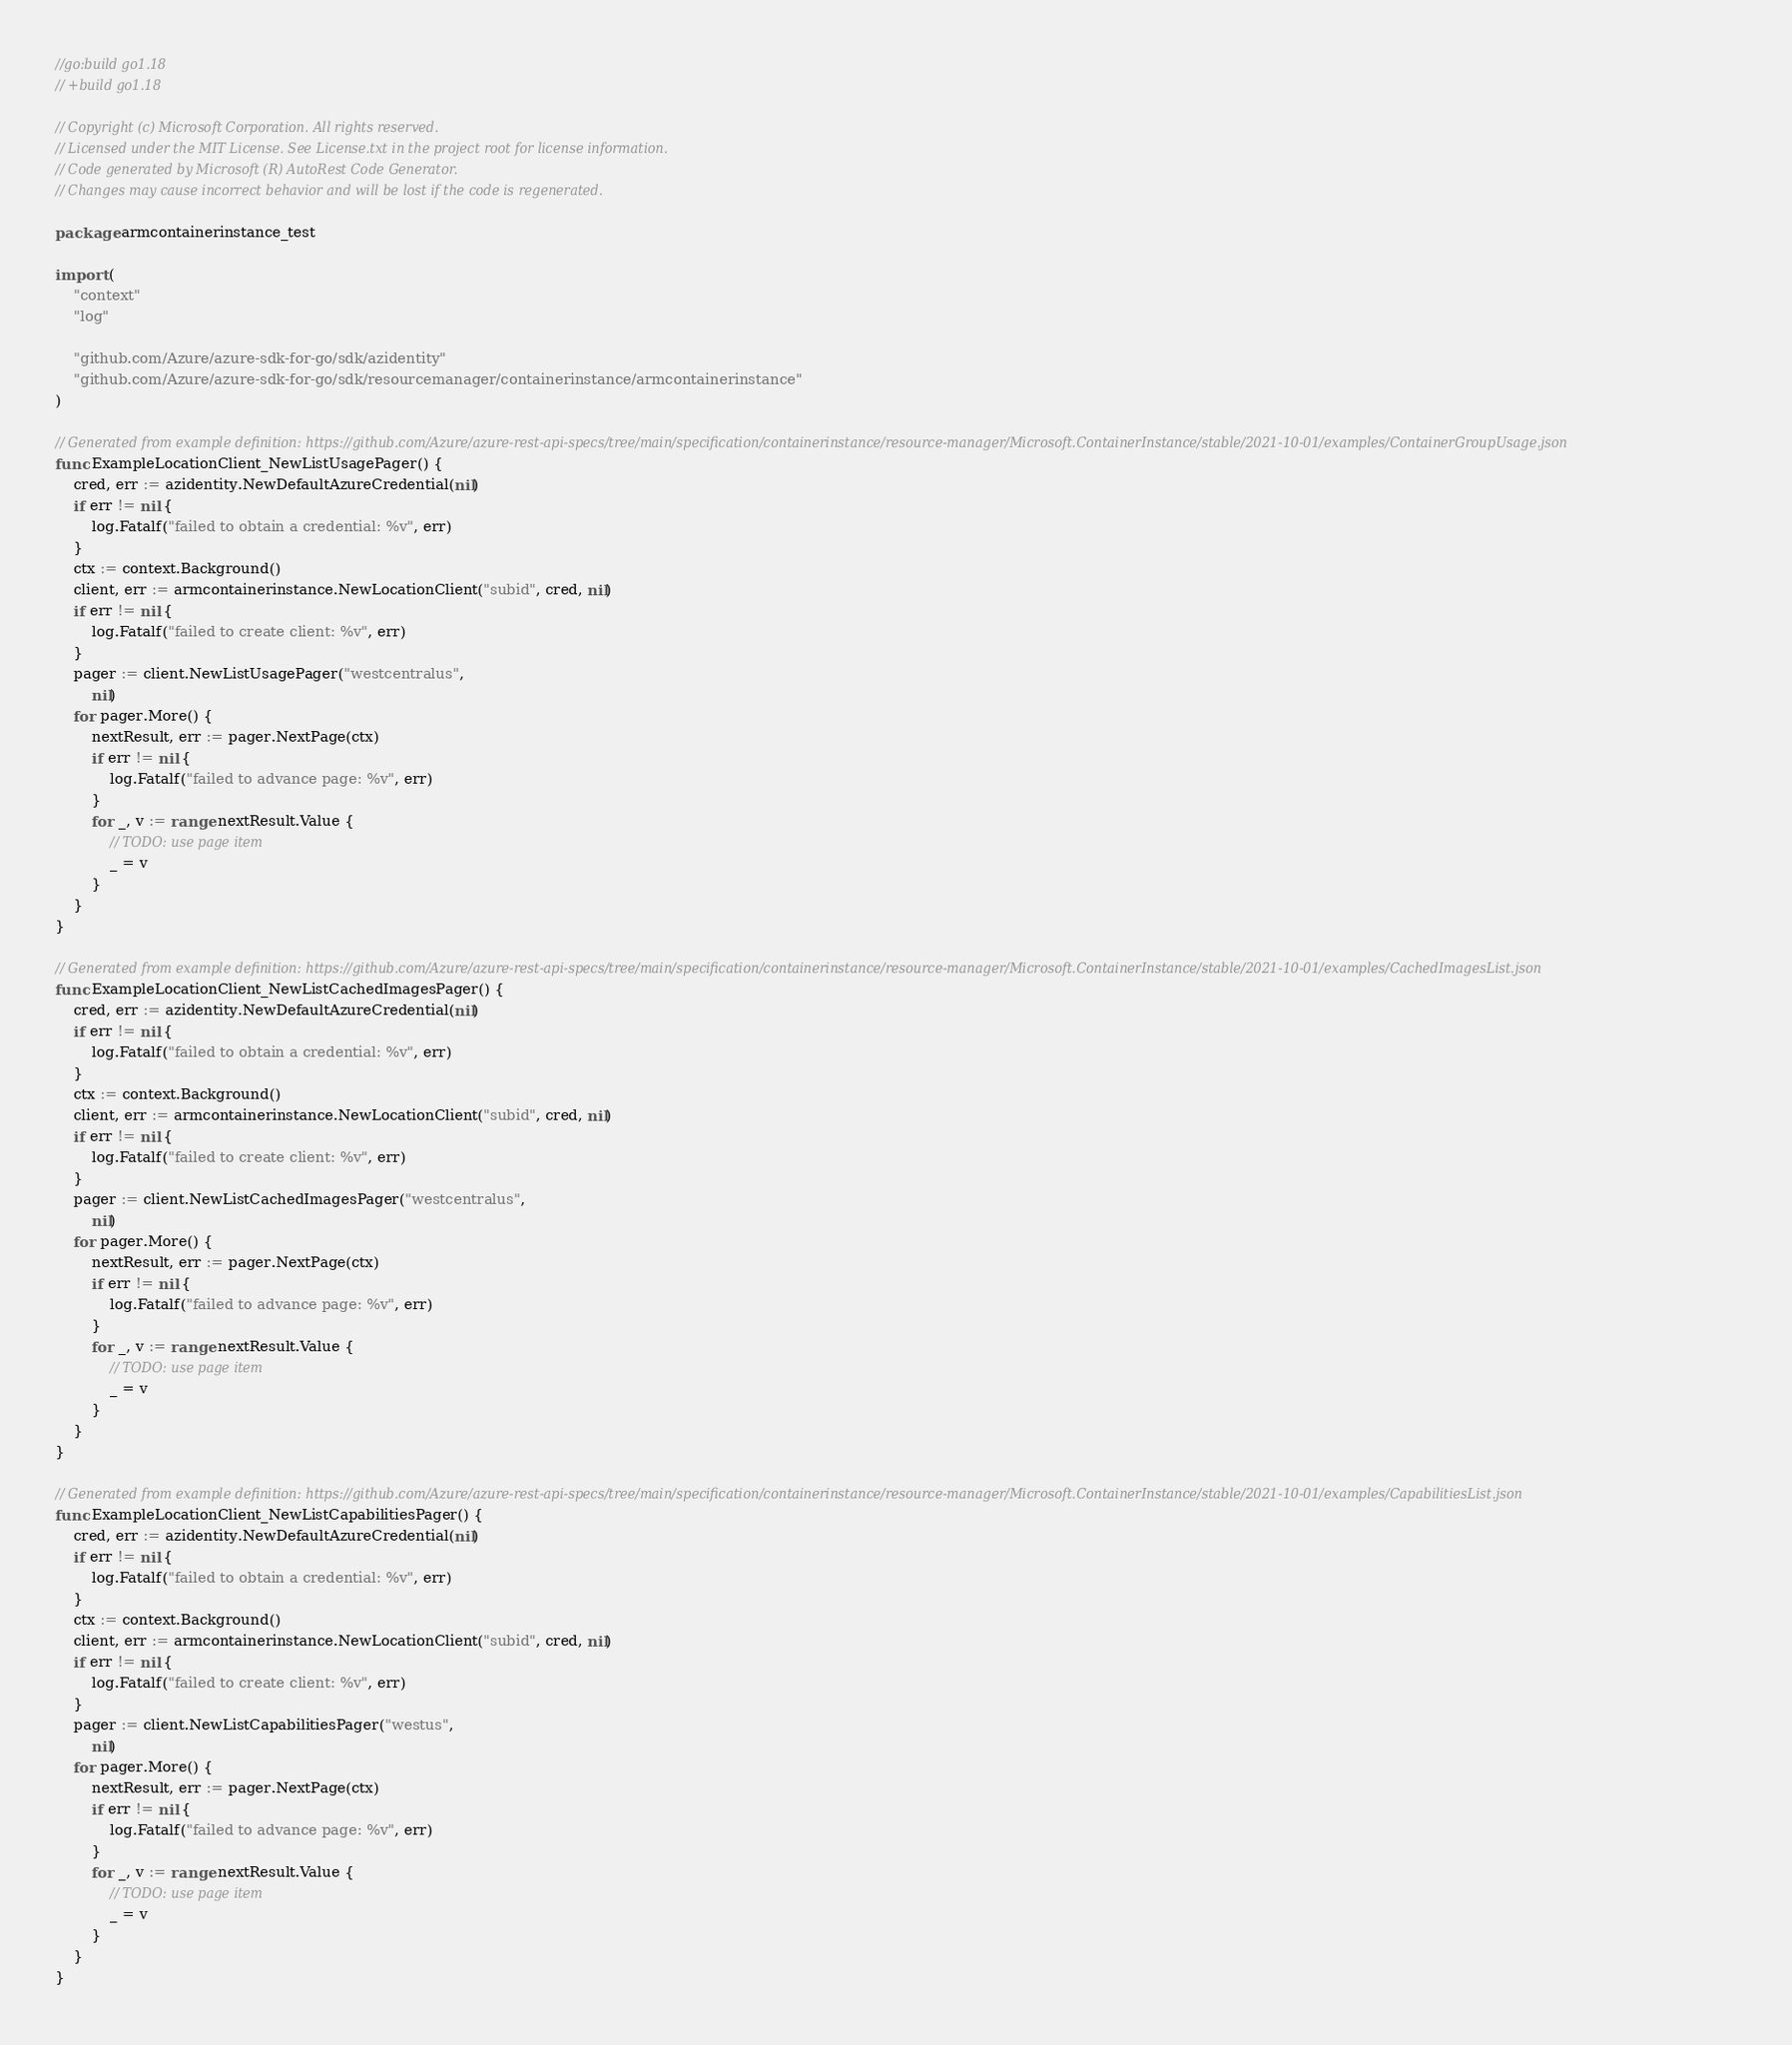Convert code to text. <code><loc_0><loc_0><loc_500><loc_500><_Go_>//go:build go1.18
// +build go1.18

// Copyright (c) Microsoft Corporation. All rights reserved.
// Licensed under the MIT License. See License.txt in the project root for license information.
// Code generated by Microsoft (R) AutoRest Code Generator.
// Changes may cause incorrect behavior and will be lost if the code is regenerated.

package armcontainerinstance_test

import (
	"context"
	"log"

	"github.com/Azure/azure-sdk-for-go/sdk/azidentity"
	"github.com/Azure/azure-sdk-for-go/sdk/resourcemanager/containerinstance/armcontainerinstance"
)

// Generated from example definition: https://github.com/Azure/azure-rest-api-specs/tree/main/specification/containerinstance/resource-manager/Microsoft.ContainerInstance/stable/2021-10-01/examples/ContainerGroupUsage.json
func ExampleLocationClient_NewListUsagePager() {
	cred, err := azidentity.NewDefaultAzureCredential(nil)
	if err != nil {
		log.Fatalf("failed to obtain a credential: %v", err)
	}
	ctx := context.Background()
	client, err := armcontainerinstance.NewLocationClient("subid", cred, nil)
	if err != nil {
		log.Fatalf("failed to create client: %v", err)
	}
	pager := client.NewListUsagePager("westcentralus",
		nil)
	for pager.More() {
		nextResult, err := pager.NextPage(ctx)
		if err != nil {
			log.Fatalf("failed to advance page: %v", err)
		}
		for _, v := range nextResult.Value {
			// TODO: use page item
			_ = v
		}
	}
}

// Generated from example definition: https://github.com/Azure/azure-rest-api-specs/tree/main/specification/containerinstance/resource-manager/Microsoft.ContainerInstance/stable/2021-10-01/examples/CachedImagesList.json
func ExampleLocationClient_NewListCachedImagesPager() {
	cred, err := azidentity.NewDefaultAzureCredential(nil)
	if err != nil {
		log.Fatalf("failed to obtain a credential: %v", err)
	}
	ctx := context.Background()
	client, err := armcontainerinstance.NewLocationClient("subid", cred, nil)
	if err != nil {
		log.Fatalf("failed to create client: %v", err)
	}
	pager := client.NewListCachedImagesPager("westcentralus",
		nil)
	for pager.More() {
		nextResult, err := pager.NextPage(ctx)
		if err != nil {
			log.Fatalf("failed to advance page: %v", err)
		}
		for _, v := range nextResult.Value {
			// TODO: use page item
			_ = v
		}
	}
}

// Generated from example definition: https://github.com/Azure/azure-rest-api-specs/tree/main/specification/containerinstance/resource-manager/Microsoft.ContainerInstance/stable/2021-10-01/examples/CapabilitiesList.json
func ExampleLocationClient_NewListCapabilitiesPager() {
	cred, err := azidentity.NewDefaultAzureCredential(nil)
	if err != nil {
		log.Fatalf("failed to obtain a credential: %v", err)
	}
	ctx := context.Background()
	client, err := armcontainerinstance.NewLocationClient("subid", cred, nil)
	if err != nil {
		log.Fatalf("failed to create client: %v", err)
	}
	pager := client.NewListCapabilitiesPager("westus",
		nil)
	for pager.More() {
		nextResult, err := pager.NextPage(ctx)
		if err != nil {
			log.Fatalf("failed to advance page: %v", err)
		}
		for _, v := range nextResult.Value {
			// TODO: use page item
			_ = v
		}
	}
}
</code> 